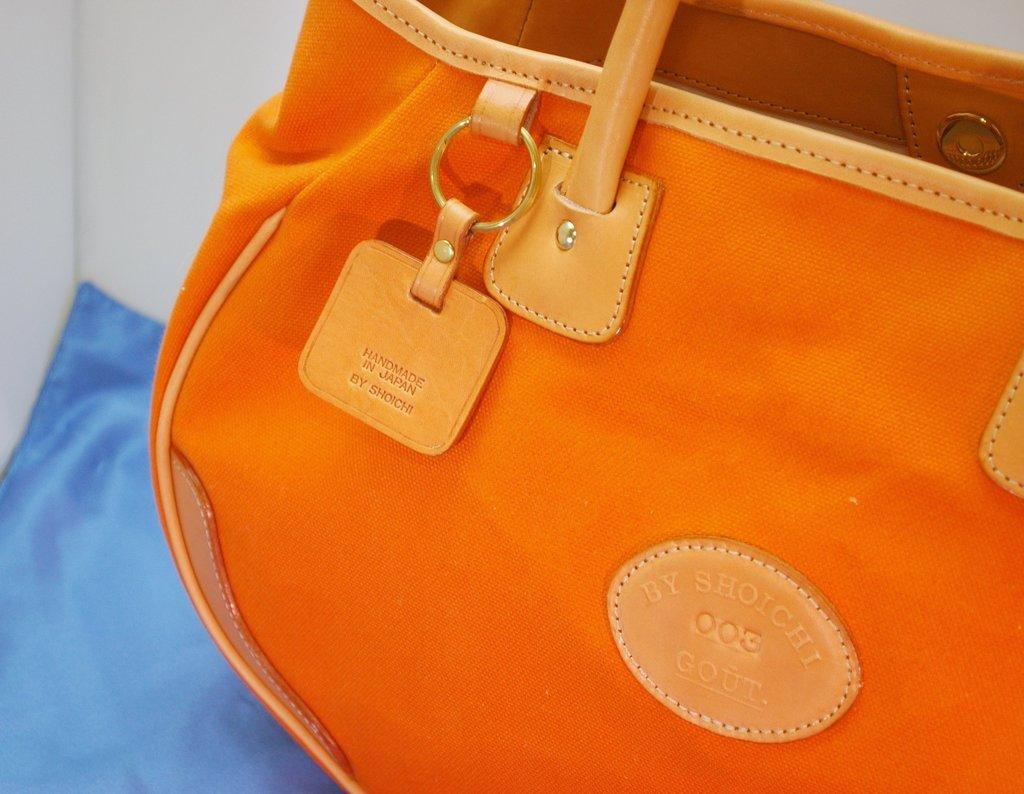What color is the bag in the image? The bag in the image is orange. What feature does the bag have? The bag has a belt. What is the bag placed on in the image? The bag is placed on a blue color cloth. Can you see any spies hiding behind the orange bag in the image? There are no spies visible in the image, as it only features an orange bag with a belt placed on a blue color cloth. 